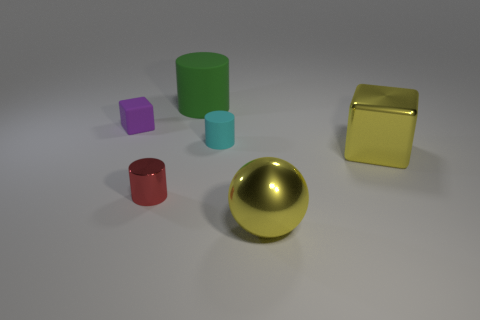Subtract all matte cylinders. How many cylinders are left? 1 Subtract 2 cylinders. How many cylinders are left? 1 Subtract all balls. How many objects are left? 5 Subtract all brown cylinders. Subtract all brown balls. How many cylinders are left? 3 Subtract all cyan blocks. How many green cylinders are left? 1 Subtract all red cylinders. Subtract all small cyan rubber spheres. How many objects are left? 5 Add 5 cyan rubber things. How many cyan rubber things are left? 6 Add 5 large gray metal objects. How many large gray metal objects exist? 5 Add 1 big red metal things. How many objects exist? 7 Subtract all red cylinders. How many cylinders are left? 2 